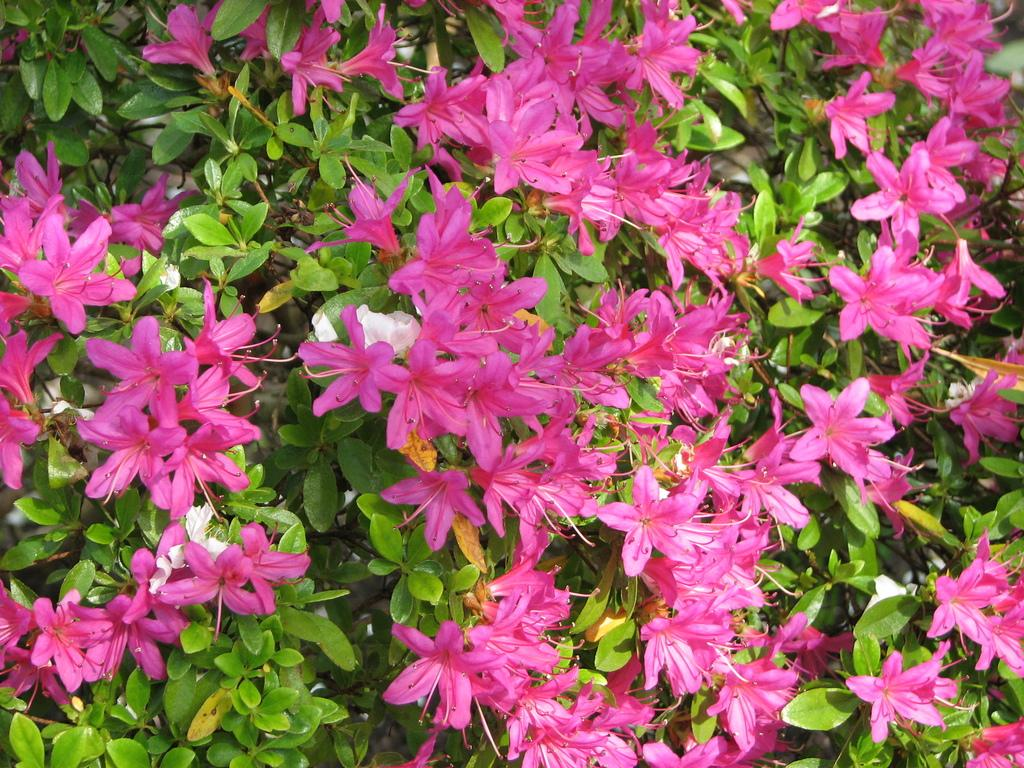What type of vegetation is present in the image? There are plants or trees in the image. What specific feature can be observed on the plants or trees? The plants or trees have flowers. What color are the flowers in the image? The flowers are in pink color. Can you tell me how many rabbits are sitting on the flowers in the image? There are no rabbits present in the image; it only features plants or trees with pink flowers. 